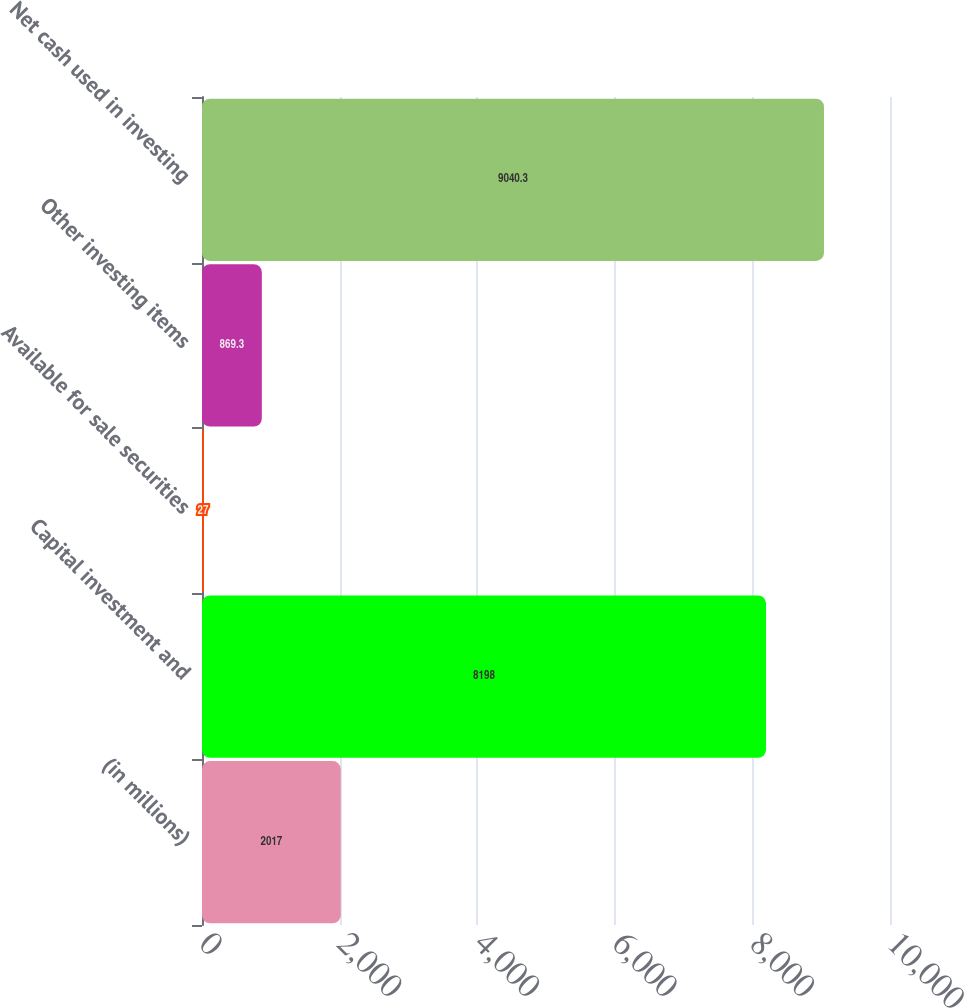Convert chart. <chart><loc_0><loc_0><loc_500><loc_500><bar_chart><fcel>(in millions)<fcel>Capital investment and<fcel>Available for sale securities<fcel>Other investing items<fcel>Net cash used in investing<nl><fcel>2017<fcel>8198<fcel>27<fcel>869.3<fcel>9040.3<nl></chart> 